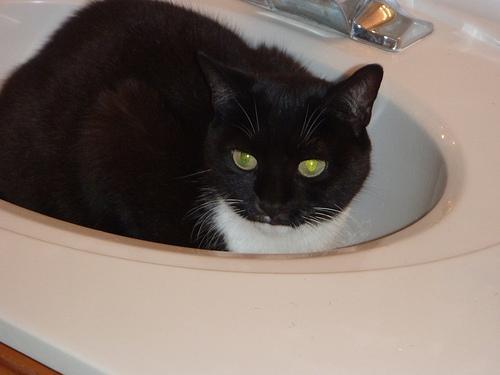How many cats are seen?
Give a very brief answer. 1. 